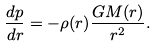Convert formula to latex. <formula><loc_0><loc_0><loc_500><loc_500>\frac { d p } { d r } = - \rho ( r ) \frac { G M ( r ) } { r ^ { 2 } } .</formula> 